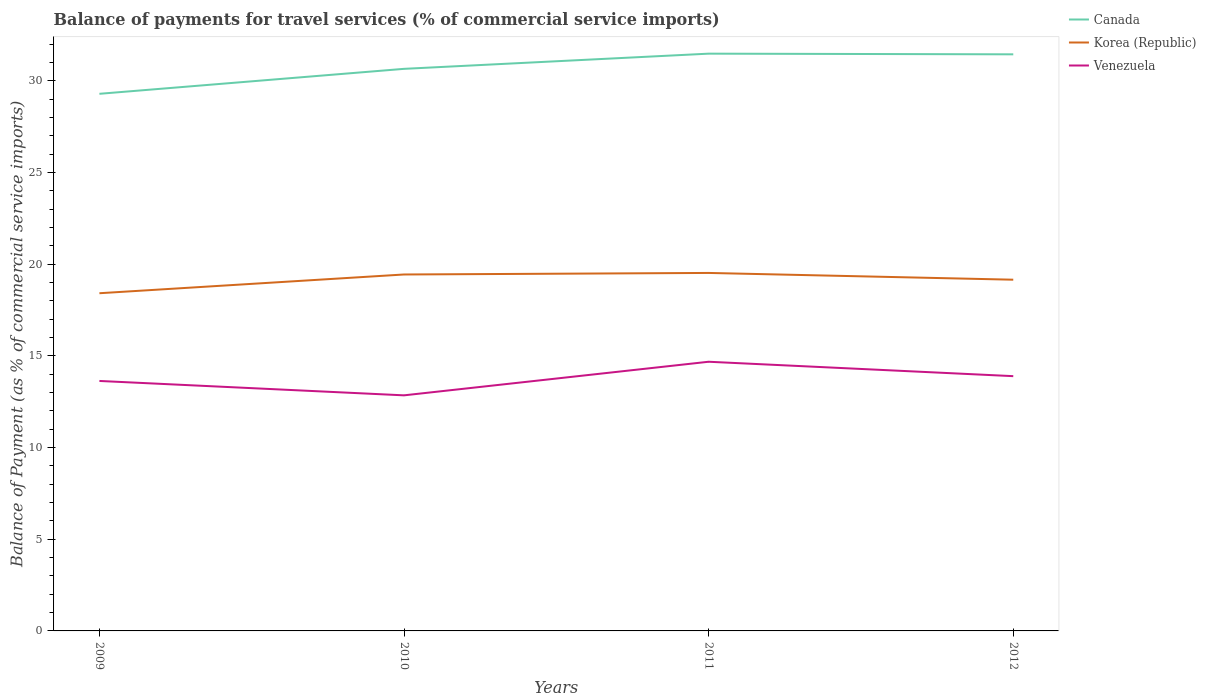Does the line corresponding to Korea (Republic) intersect with the line corresponding to Venezuela?
Your response must be concise. No. Is the number of lines equal to the number of legend labels?
Your answer should be compact. Yes. Across all years, what is the maximum balance of payments for travel services in Korea (Republic)?
Your response must be concise. 18.41. In which year was the balance of payments for travel services in Korea (Republic) maximum?
Your response must be concise. 2009. What is the total balance of payments for travel services in Korea (Republic) in the graph?
Ensure brevity in your answer.  0.28. What is the difference between the highest and the second highest balance of payments for travel services in Venezuela?
Offer a terse response. 1.83. Is the balance of payments for travel services in Venezuela strictly greater than the balance of payments for travel services in Korea (Republic) over the years?
Provide a succinct answer. Yes. What is the difference between two consecutive major ticks on the Y-axis?
Keep it short and to the point. 5. Does the graph contain any zero values?
Give a very brief answer. No. How many legend labels are there?
Make the answer very short. 3. How are the legend labels stacked?
Give a very brief answer. Vertical. What is the title of the graph?
Ensure brevity in your answer.  Balance of payments for travel services (% of commercial service imports). Does "Niger" appear as one of the legend labels in the graph?
Make the answer very short. No. What is the label or title of the X-axis?
Offer a terse response. Years. What is the label or title of the Y-axis?
Your answer should be very brief. Balance of Payment (as % of commercial service imports). What is the Balance of Payment (as % of commercial service imports) in Canada in 2009?
Offer a very short reply. 29.29. What is the Balance of Payment (as % of commercial service imports) in Korea (Republic) in 2009?
Your answer should be compact. 18.41. What is the Balance of Payment (as % of commercial service imports) in Venezuela in 2009?
Your answer should be very brief. 13.63. What is the Balance of Payment (as % of commercial service imports) in Canada in 2010?
Make the answer very short. 30.65. What is the Balance of Payment (as % of commercial service imports) of Korea (Republic) in 2010?
Provide a short and direct response. 19.44. What is the Balance of Payment (as % of commercial service imports) of Venezuela in 2010?
Give a very brief answer. 12.85. What is the Balance of Payment (as % of commercial service imports) of Canada in 2011?
Your answer should be compact. 31.48. What is the Balance of Payment (as % of commercial service imports) in Korea (Republic) in 2011?
Offer a very short reply. 19.52. What is the Balance of Payment (as % of commercial service imports) in Venezuela in 2011?
Provide a short and direct response. 14.68. What is the Balance of Payment (as % of commercial service imports) of Canada in 2012?
Your response must be concise. 31.44. What is the Balance of Payment (as % of commercial service imports) in Korea (Republic) in 2012?
Offer a very short reply. 19.15. What is the Balance of Payment (as % of commercial service imports) of Venezuela in 2012?
Ensure brevity in your answer.  13.89. Across all years, what is the maximum Balance of Payment (as % of commercial service imports) in Canada?
Give a very brief answer. 31.48. Across all years, what is the maximum Balance of Payment (as % of commercial service imports) in Korea (Republic)?
Offer a terse response. 19.52. Across all years, what is the maximum Balance of Payment (as % of commercial service imports) in Venezuela?
Keep it short and to the point. 14.68. Across all years, what is the minimum Balance of Payment (as % of commercial service imports) of Canada?
Keep it short and to the point. 29.29. Across all years, what is the minimum Balance of Payment (as % of commercial service imports) of Korea (Republic)?
Keep it short and to the point. 18.41. Across all years, what is the minimum Balance of Payment (as % of commercial service imports) of Venezuela?
Offer a very short reply. 12.85. What is the total Balance of Payment (as % of commercial service imports) in Canada in the graph?
Your answer should be very brief. 122.86. What is the total Balance of Payment (as % of commercial service imports) of Korea (Republic) in the graph?
Provide a short and direct response. 76.53. What is the total Balance of Payment (as % of commercial service imports) in Venezuela in the graph?
Your answer should be compact. 55.05. What is the difference between the Balance of Payment (as % of commercial service imports) of Canada in 2009 and that in 2010?
Your answer should be very brief. -1.36. What is the difference between the Balance of Payment (as % of commercial service imports) in Korea (Republic) in 2009 and that in 2010?
Provide a short and direct response. -1.02. What is the difference between the Balance of Payment (as % of commercial service imports) in Venezuela in 2009 and that in 2010?
Ensure brevity in your answer.  0.78. What is the difference between the Balance of Payment (as % of commercial service imports) in Canada in 2009 and that in 2011?
Give a very brief answer. -2.19. What is the difference between the Balance of Payment (as % of commercial service imports) in Korea (Republic) in 2009 and that in 2011?
Your response must be concise. -1.11. What is the difference between the Balance of Payment (as % of commercial service imports) of Venezuela in 2009 and that in 2011?
Your answer should be compact. -1.05. What is the difference between the Balance of Payment (as % of commercial service imports) of Canada in 2009 and that in 2012?
Make the answer very short. -2.15. What is the difference between the Balance of Payment (as % of commercial service imports) of Korea (Republic) in 2009 and that in 2012?
Your answer should be very brief. -0.74. What is the difference between the Balance of Payment (as % of commercial service imports) of Venezuela in 2009 and that in 2012?
Make the answer very short. -0.26. What is the difference between the Balance of Payment (as % of commercial service imports) of Canada in 2010 and that in 2011?
Provide a succinct answer. -0.83. What is the difference between the Balance of Payment (as % of commercial service imports) of Korea (Republic) in 2010 and that in 2011?
Your response must be concise. -0.08. What is the difference between the Balance of Payment (as % of commercial service imports) of Venezuela in 2010 and that in 2011?
Give a very brief answer. -1.83. What is the difference between the Balance of Payment (as % of commercial service imports) of Canada in 2010 and that in 2012?
Your answer should be compact. -0.79. What is the difference between the Balance of Payment (as % of commercial service imports) of Korea (Republic) in 2010 and that in 2012?
Make the answer very short. 0.28. What is the difference between the Balance of Payment (as % of commercial service imports) of Venezuela in 2010 and that in 2012?
Ensure brevity in your answer.  -1.05. What is the difference between the Balance of Payment (as % of commercial service imports) of Canada in 2011 and that in 2012?
Provide a short and direct response. 0.04. What is the difference between the Balance of Payment (as % of commercial service imports) of Korea (Republic) in 2011 and that in 2012?
Keep it short and to the point. 0.37. What is the difference between the Balance of Payment (as % of commercial service imports) in Venezuela in 2011 and that in 2012?
Your response must be concise. 0.79. What is the difference between the Balance of Payment (as % of commercial service imports) of Canada in 2009 and the Balance of Payment (as % of commercial service imports) of Korea (Republic) in 2010?
Your response must be concise. 9.85. What is the difference between the Balance of Payment (as % of commercial service imports) in Canada in 2009 and the Balance of Payment (as % of commercial service imports) in Venezuela in 2010?
Provide a short and direct response. 16.44. What is the difference between the Balance of Payment (as % of commercial service imports) of Korea (Republic) in 2009 and the Balance of Payment (as % of commercial service imports) of Venezuela in 2010?
Keep it short and to the point. 5.57. What is the difference between the Balance of Payment (as % of commercial service imports) in Canada in 2009 and the Balance of Payment (as % of commercial service imports) in Korea (Republic) in 2011?
Make the answer very short. 9.77. What is the difference between the Balance of Payment (as % of commercial service imports) of Canada in 2009 and the Balance of Payment (as % of commercial service imports) of Venezuela in 2011?
Offer a very short reply. 14.61. What is the difference between the Balance of Payment (as % of commercial service imports) of Korea (Republic) in 2009 and the Balance of Payment (as % of commercial service imports) of Venezuela in 2011?
Your answer should be very brief. 3.74. What is the difference between the Balance of Payment (as % of commercial service imports) of Canada in 2009 and the Balance of Payment (as % of commercial service imports) of Korea (Republic) in 2012?
Provide a short and direct response. 10.14. What is the difference between the Balance of Payment (as % of commercial service imports) of Canada in 2009 and the Balance of Payment (as % of commercial service imports) of Venezuela in 2012?
Your response must be concise. 15.4. What is the difference between the Balance of Payment (as % of commercial service imports) in Korea (Republic) in 2009 and the Balance of Payment (as % of commercial service imports) in Venezuela in 2012?
Make the answer very short. 4.52. What is the difference between the Balance of Payment (as % of commercial service imports) of Canada in 2010 and the Balance of Payment (as % of commercial service imports) of Korea (Republic) in 2011?
Your answer should be compact. 11.13. What is the difference between the Balance of Payment (as % of commercial service imports) in Canada in 2010 and the Balance of Payment (as % of commercial service imports) in Venezuela in 2011?
Your response must be concise. 15.97. What is the difference between the Balance of Payment (as % of commercial service imports) of Korea (Republic) in 2010 and the Balance of Payment (as % of commercial service imports) of Venezuela in 2011?
Your answer should be compact. 4.76. What is the difference between the Balance of Payment (as % of commercial service imports) of Canada in 2010 and the Balance of Payment (as % of commercial service imports) of Korea (Republic) in 2012?
Your answer should be compact. 11.5. What is the difference between the Balance of Payment (as % of commercial service imports) of Canada in 2010 and the Balance of Payment (as % of commercial service imports) of Venezuela in 2012?
Keep it short and to the point. 16.76. What is the difference between the Balance of Payment (as % of commercial service imports) in Korea (Republic) in 2010 and the Balance of Payment (as % of commercial service imports) in Venezuela in 2012?
Keep it short and to the point. 5.54. What is the difference between the Balance of Payment (as % of commercial service imports) of Canada in 2011 and the Balance of Payment (as % of commercial service imports) of Korea (Republic) in 2012?
Offer a very short reply. 12.33. What is the difference between the Balance of Payment (as % of commercial service imports) of Canada in 2011 and the Balance of Payment (as % of commercial service imports) of Venezuela in 2012?
Give a very brief answer. 17.59. What is the difference between the Balance of Payment (as % of commercial service imports) of Korea (Republic) in 2011 and the Balance of Payment (as % of commercial service imports) of Venezuela in 2012?
Offer a very short reply. 5.63. What is the average Balance of Payment (as % of commercial service imports) of Canada per year?
Offer a very short reply. 30.72. What is the average Balance of Payment (as % of commercial service imports) in Korea (Republic) per year?
Give a very brief answer. 19.13. What is the average Balance of Payment (as % of commercial service imports) in Venezuela per year?
Offer a terse response. 13.76. In the year 2009, what is the difference between the Balance of Payment (as % of commercial service imports) in Canada and Balance of Payment (as % of commercial service imports) in Korea (Republic)?
Offer a terse response. 10.87. In the year 2009, what is the difference between the Balance of Payment (as % of commercial service imports) in Canada and Balance of Payment (as % of commercial service imports) in Venezuela?
Ensure brevity in your answer.  15.66. In the year 2009, what is the difference between the Balance of Payment (as % of commercial service imports) in Korea (Republic) and Balance of Payment (as % of commercial service imports) in Venezuela?
Your answer should be very brief. 4.78. In the year 2010, what is the difference between the Balance of Payment (as % of commercial service imports) in Canada and Balance of Payment (as % of commercial service imports) in Korea (Republic)?
Your answer should be very brief. 11.21. In the year 2010, what is the difference between the Balance of Payment (as % of commercial service imports) in Canada and Balance of Payment (as % of commercial service imports) in Venezuela?
Your answer should be very brief. 17.8. In the year 2010, what is the difference between the Balance of Payment (as % of commercial service imports) of Korea (Republic) and Balance of Payment (as % of commercial service imports) of Venezuela?
Provide a short and direct response. 6.59. In the year 2011, what is the difference between the Balance of Payment (as % of commercial service imports) in Canada and Balance of Payment (as % of commercial service imports) in Korea (Republic)?
Provide a short and direct response. 11.96. In the year 2011, what is the difference between the Balance of Payment (as % of commercial service imports) in Canada and Balance of Payment (as % of commercial service imports) in Venezuela?
Make the answer very short. 16.8. In the year 2011, what is the difference between the Balance of Payment (as % of commercial service imports) in Korea (Republic) and Balance of Payment (as % of commercial service imports) in Venezuela?
Your answer should be compact. 4.84. In the year 2012, what is the difference between the Balance of Payment (as % of commercial service imports) of Canada and Balance of Payment (as % of commercial service imports) of Korea (Republic)?
Offer a terse response. 12.29. In the year 2012, what is the difference between the Balance of Payment (as % of commercial service imports) of Canada and Balance of Payment (as % of commercial service imports) of Venezuela?
Give a very brief answer. 17.55. In the year 2012, what is the difference between the Balance of Payment (as % of commercial service imports) in Korea (Republic) and Balance of Payment (as % of commercial service imports) in Venezuela?
Your response must be concise. 5.26. What is the ratio of the Balance of Payment (as % of commercial service imports) in Canada in 2009 to that in 2010?
Keep it short and to the point. 0.96. What is the ratio of the Balance of Payment (as % of commercial service imports) of Venezuela in 2009 to that in 2010?
Give a very brief answer. 1.06. What is the ratio of the Balance of Payment (as % of commercial service imports) in Canada in 2009 to that in 2011?
Provide a short and direct response. 0.93. What is the ratio of the Balance of Payment (as % of commercial service imports) of Korea (Republic) in 2009 to that in 2011?
Your response must be concise. 0.94. What is the ratio of the Balance of Payment (as % of commercial service imports) in Canada in 2009 to that in 2012?
Offer a very short reply. 0.93. What is the ratio of the Balance of Payment (as % of commercial service imports) in Korea (Republic) in 2009 to that in 2012?
Ensure brevity in your answer.  0.96. What is the ratio of the Balance of Payment (as % of commercial service imports) of Venezuela in 2009 to that in 2012?
Give a very brief answer. 0.98. What is the ratio of the Balance of Payment (as % of commercial service imports) of Canada in 2010 to that in 2011?
Make the answer very short. 0.97. What is the ratio of the Balance of Payment (as % of commercial service imports) in Venezuela in 2010 to that in 2011?
Offer a terse response. 0.88. What is the ratio of the Balance of Payment (as % of commercial service imports) of Canada in 2010 to that in 2012?
Offer a terse response. 0.97. What is the ratio of the Balance of Payment (as % of commercial service imports) of Korea (Republic) in 2010 to that in 2012?
Make the answer very short. 1.01. What is the ratio of the Balance of Payment (as % of commercial service imports) of Venezuela in 2010 to that in 2012?
Ensure brevity in your answer.  0.92. What is the ratio of the Balance of Payment (as % of commercial service imports) of Korea (Republic) in 2011 to that in 2012?
Provide a succinct answer. 1.02. What is the ratio of the Balance of Payment (as % of commercial service imports) of Venezuela in 2011 to that in 2012?
Give a very brief answer. 1.06. What is the difference between the highest and the second highest Balance of Payment (as % of commercial service imports) in Canada?
Ensure brevity in your answer.  0.04. What is the difference between the highest and the second highest Balance of Payment (as % of commercial service imports) in Korea (Republic)?
Provide a succinct answer. 0.08. What is the difference between the highest and the second highest Balance of Payment (as % of commercial service imports) of Venezuela?
Offer a very short reply. 0.79. What is the difference between the highest and the lowest Balance of Payment (as % of commercial service imports) in Canada?
Ensure brevity in your answer.  2.19. What is the difference between the highest and the lowest Balance of Payment (as % of commercial service imports) of Korea (Republic)?
Your answer should be compact. 1.11. What is the difference between the highest and the lowest Balance of Payment (as % of commercial service imports) of Venezuela?
Offer a very short reply. 1.83. 